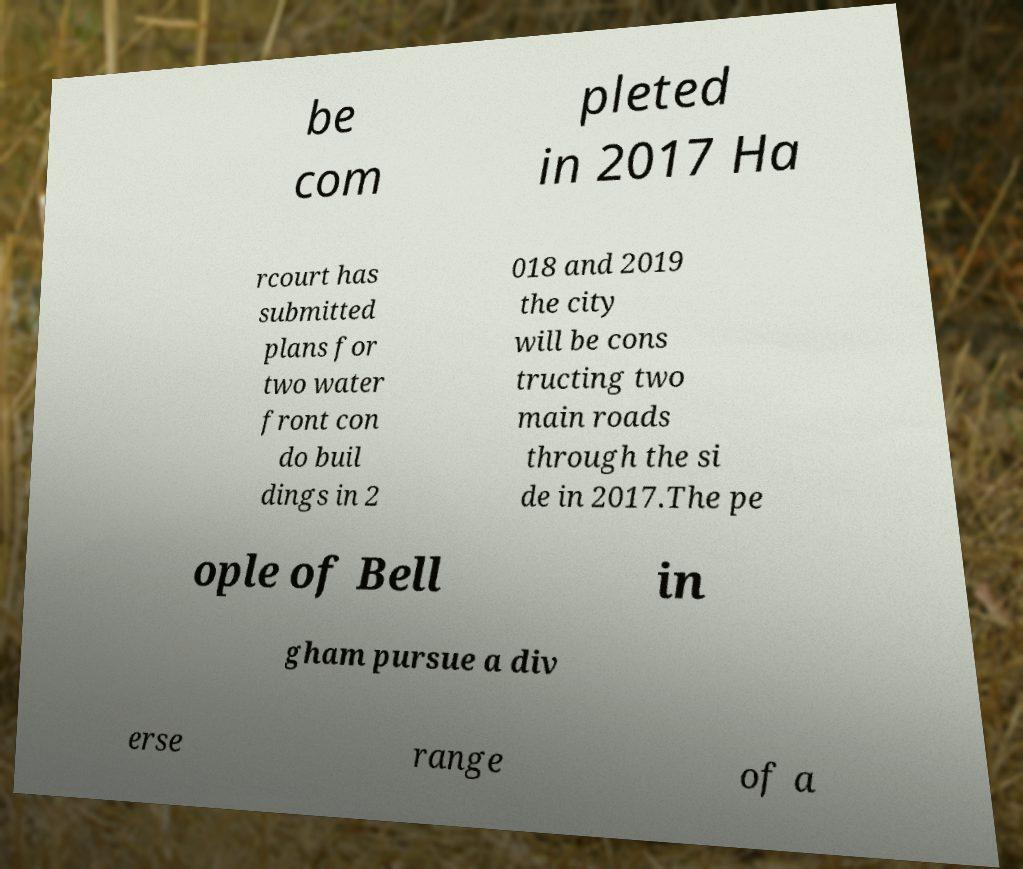There's text embedded in this image that I need extracted. Can you transcribe it verbatim? be com pleted in 2017 Ha rcourt has submitted plans for two water front con do buil dings in 2 018 and 2019 the city will be cons tructing two main roads through the si de in 2017.The pe ople of Bell in gham pursue a div erse range of a 